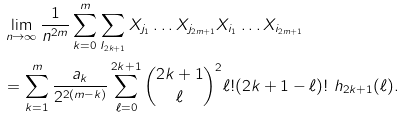<formula> <loc_0><loc_0><loc_500><loc_500>& \lim _ { n \to \infty } \frac { 1 } { n ^ { 2 m } } \sum _ { k = 0 } ^ { m } \sum _ { I _ { 2 k + 1 } } X _ { j _ { 1 } } \dots X _ { j _ { 2 m + 1 } } X _ { i _ { 1 } } \dots X _ { i _ { 2 m + 1 } } \\ & = \sum _ { k = 1 } ^ { m } \frac { a _ { k } } { 2 ^ { 2 ( m - k ) } } \sum _ { \ell = 0 } ^ { 2 k + 1 } \binom { 2 k + 1 } { \ell } ^ { 2 } \ell ! ( 2 k + 1 - \ell ) ! \ h _ { 2 k + 1 } ( \ell ) .</formula> 